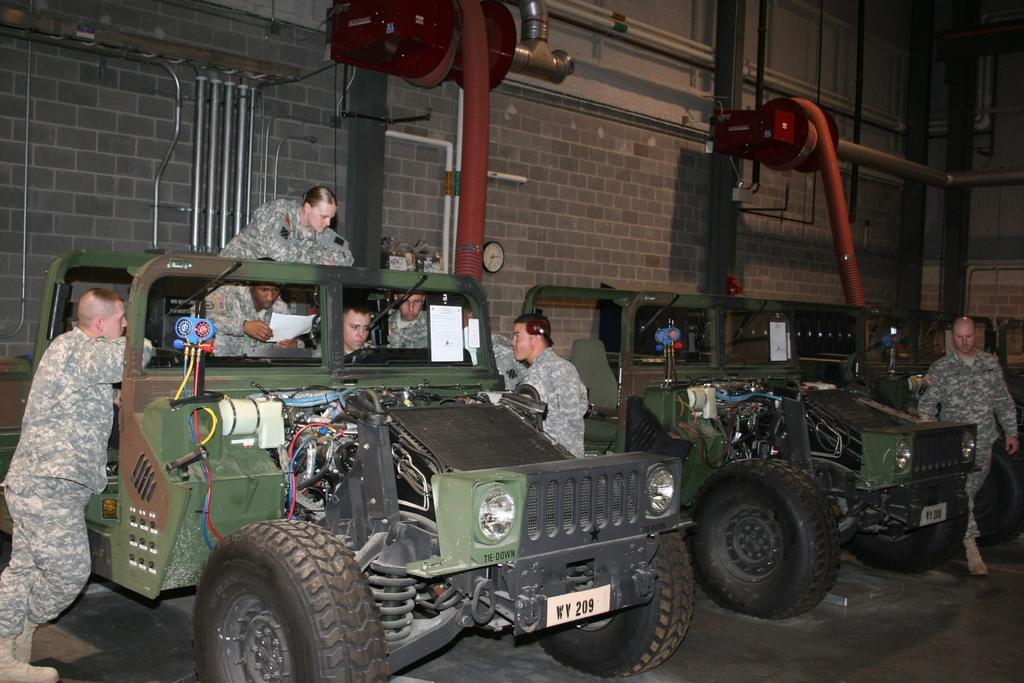What vehicle is present in the image? There is a jeep in the image. What features can be seen on the jeep? The jeep has a tire and a light. Who is inside the jeep? There are people sitting in the jeep. Are there any people near the jeep? Yes, there are people standing near the jeep. What is visible in the background of the image? There is a wall in the image. What type of salt is being used to season the food in the image? There is no food or salt present in the image; it features a jeep with people inside and near it, as well as a wall in the background. 